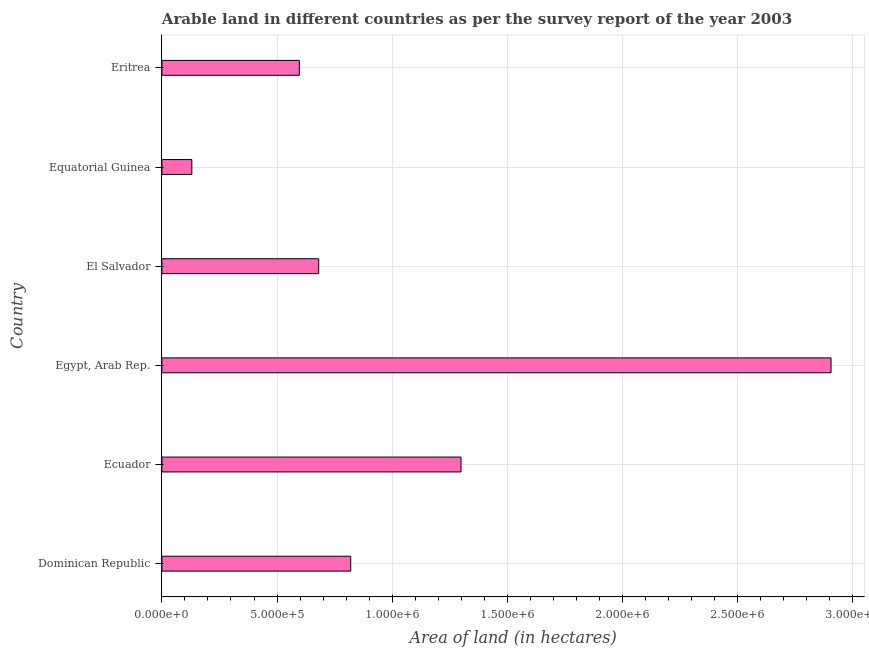Does the graph contain any zero values?
Provide a short and direct response. No. What is the title of the graph?
Provide a succinct answer. Arable land in different countries as per the survey report of the year 2003. What is the label or title of the X-axis?
Offer a terse response. Area of land (in hectares). What is the label or title of the Y-axis?
Ensure brevity in your answer.  Country. What is the area of land in Egypt, Arab Rep.?
Make the answer very short. 2.91e+06. Across all countries, what is the maximum area of land?
Give a very brief answer. 2.91e+06. Across all countries, what is the minimum area of land?
Offer a terse response. 1.30e+05. In which country was the area of land maximum?
Offer a terse response. Egypt, Arab Rep. In which country was the area of land minimum?
Your response must be concise. Equatorial Guinea. What is the sum of the area of land?
Keep it short and to the point. 6.43e+06. What is the difference between the area of land in Ecuador and El Salvador?
Provide a short and direct response. 6.18e+05. What is the average area of land per country?
Keep it short and to the point. 1.07e+06. What is the median area of land?
Make the answer very short. 7.50e+05. In how many countries, is the area of land greater than 1100000 hectares?
Keep it short and to the point. 2. What is the ratio of the area of land in Dominican Republic to that in Egypt, Arab Rep.?
Provide a succinct answer. 0.28. Is the area of land in Dominican Republic less than that in Equatorial Guinea?
Your response must be concise. No. Is the difference between the area of land in Egypt, Arab Rep. and El Salvador greater than the difference between any two countries?
Ensure brevity in your answer.  No. What is the difference between the highest and the second highest area of land?
Make the answer very short. 1.61e+06. Is the sum of the area of land in Dominican Republic and Equatorial Guinea greater than the maximum area of land across all countries?
Your answer should be very brief. No. What is the difference between the highest and the lowest area of land?
Give a very brief answer. 2.78e+06. In how many countries, is the area of land greater than the average area of land taken over all countries?
Your answer should be compact. 2. How many bars are there?
Give a very brief answer. 6. Are all the bars in the graph horizontal?
Your answer should be compact. Yes. What is the Area of land (in hectares) in Dominican Republic?
Provide a succinct answer. 8.20e+05. What is the Area of land (in hectares) of Ecuador?
Make the answer very short. 1.30e+06. What is the Area of land (in hectares) in Egypt, Arab Rep.?
Offer a terse response. 2.91e+06. What is the Area of land (in hectares) in El Salvador?
Offer a very short reply. 6.81e+05. What is the Area of land (in hectares) of Eritrea?
Provide a succinct answer. 5.97e+05. What is the difference between the Area of land (in hectares) in Dominican Republic and Ecuador?
Provide a short and direct response. -4.79e+05. What is the difference between the Area of land (in hectares) in Dominican Republic and Egypt, Arab Rep.?
Keep it short and to the point. -2.09e+06. What is the difference between the Area of land (in hectares) in Dominican Republic and El Salvador?
Provide a succinct answer. 1.39e+05. What is the difference between the Area of land (in hectares) in Dominican Republic and Equatorial Guinea?
Offer a very short reply. 6.90e+05. What is the difference between the Area of land (in hectares) in Dominican Republic and Eritrea?
Your response must be concise. 2.23e+05. What is the difference between the Area of land (in hectares) in Ecuador and Egypt, Arab Rep.?
Keep it short and to the point. -1.61e+06. What is the difference between the Area of land (in hectares) in Ecuador and El Salvador?
Make the answer very short. 6.18e+05. What is the difference between the Area of land (in hectares) in Ecuador and Equatorial Guinea?
Make the answer very short. 1.17e+06. What is the difference between the Area of land (in hectares) in Ecuador and Eritrea?
Your response must be concise. 7.02e+05. What is the difference between the Area of land (in hectares) in Egypt, Arab Rep. and El Salvador?
Your answer should be very brief. 2.22e+06. What is the difference between the Area of land (in hectares) in Egypt, Arab Rep. and Equatorial Guinea?
Make the answer very short. 2.78e+06. What is the difference between the Area of land (in hectares) in Egypt, Arab Rep. and Eritrea?
Provide a succinct answer. 2.31e+06. What is the difference between the Area of land (in hectares) in El Salvador and Equatorial Guinea?
Give a very brief answer. 5.51e+05. What is the difference between the Area of land (in hectares) in El Salvador and Eritrea?
Give a very brief answer. 8.40e+04. What is the difference between the Area of land (in hectares) in Equatorial Guinea and Eritrea?
Give a very brief answer. -4.67e+05. What is the ratio of the Area of land (in hectares) in Dominican Republic to that in Ecuador?
Make the answer very short. 0.63. What is the ratio of the Area of land (in hectares) in Dominican Republic to that in Egypt, Arab Rep.?
Ensure brevity in your answer.  0.28. What is the ratio of the Area of land (in hectares) in Dominican Republic to that in El Salvador?
Provide a succinct answer. 1.2. What is the ratio of the Area of land (in hectares) in Dominican Republic to that in Equatorial Guinea?
Make the answer very short. 6.31. What is the ratio of the Area of land (in hectares) in Dominican Republic to that in Eritrea?
Provide a succinct answer. 1.37. What is the ratio of the Area of land (in hectares) in Ecuador to that in Egypt, Arab Rep.?
Give a very brief answer. 0.45. What is the ratio of the Area of land (in hectares) in Ecuador to that in El Salvador?
Provide a short and direct response. 1.91. What is the ratio of the Area of land (in hectares) in Ecuador to that in Equatorial Guinea?
Offer a very short reply. 9.99. What is the ratio of the Area of land (in hectares) in Ecuador to that in Eritrea?
Offer a very short reply. 2.18. What is the ratio of the Area of land (in hectares) in Egypt, Arab Rep. to that in El Salvador?
Your answer should be compact. 4.27. What is the ratio of the Area of land (in hectares) in Egypt, Arab Rep. to that in Equatorial Guinea?
Your answer should be compact. 22.35. What is the ratio of the Area of land (in hectares) in Egypt, Arab Rep. to that in Eritrea?
Your response must be concise. 4.87. What is the ratio of the Area of land (in hectares) in El Salvador to that in Equatorial Guinea?
Give a very brief answer. 5.24. What is the ratio of the Area of land (in hectares) in El Salvador to that in Eritrea?
Offer a very short reply. 1.14. What is the ratio of the Area of land (in hectares) in Equatorial Guinea to that in Eritrea?
Your response must be concise. 0.22. 